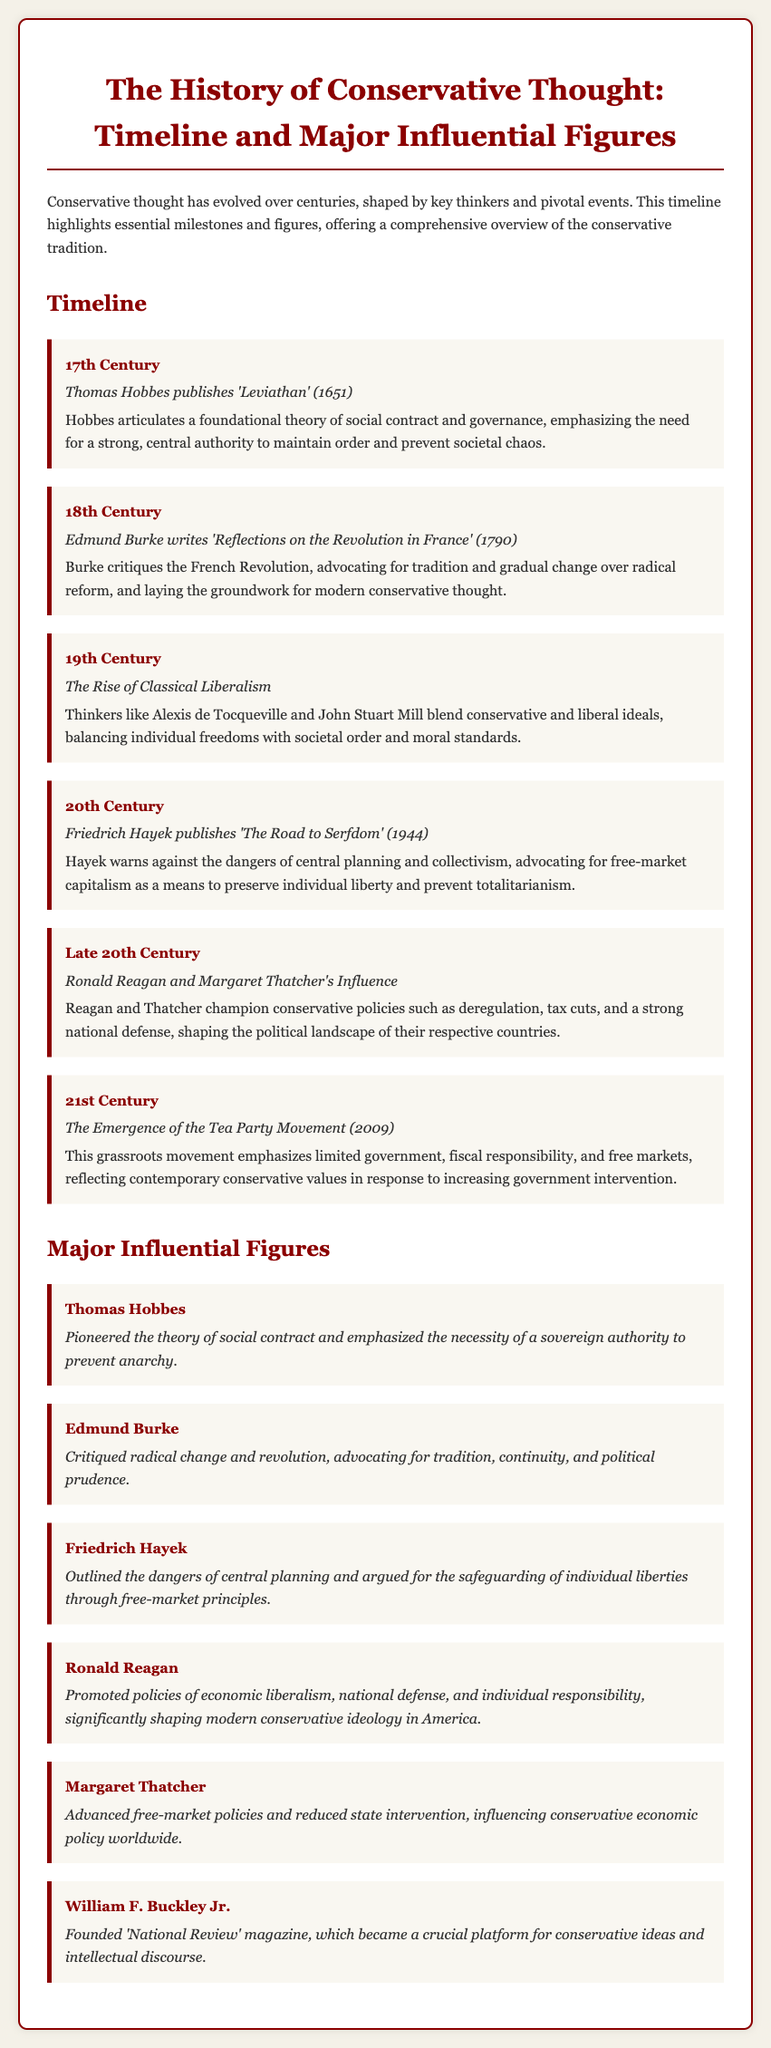What event did Thomas Hobbes publish in 1651? The document states that Hobbes published 'Leviathan' in 1651, which is a foundational work in conservative thought.
Answer: 'Leviathan' What critique did Edmund Burke present in 1790? Burke's critique in 'Reflections on the Revolution in France' focuses on radical reform, advocating for tradition and gradual change.
Answer: Radical reform Who warned against collectivism in 1944? The document mentions Friedrich Hayek published 'The Road to Serfdom' in 1944, warning against the dangers of collectivism.
Answer: Friedrich Hayek Which two leaders shaped conservative policies in the late 20th century? The document indicates that Ronald Reagan and Margaret Thatcher were influential in shaping conservative policies during that time.
Answer: Ronald Reagan and Margaret Thatcher What grassroots movement emerged in 2009? The document states that the Tea Party Movement emerged in 2009, emphasizing limited government and fiscal responsibility.
Answer: Tea Party Movement What philosophical theory did Thomas Hobbes pioneer? The document notes that Hobbes pioneered the theory of social contract, emphasizing the need for a sovereign authority.
Answer: Theory of social contract How did Margaret Thatcher influence economic policy? The document explains that Thatcher advanced free-market policies and reduced state intervention, influencing global conservative economic policies.
Answer: Advanced free-market policies What magazine did William F. Buckley Jr. found? According to the document, Buckley founded 'National Review,' which became a crucial platform for conservative ideas.
Answer: 'National Review' In what century did the Rise of Classical Liberalism occur? The document specifies that the Rise of Classical Liberalism happened in the 19th Century.
Answer: 19th Century 